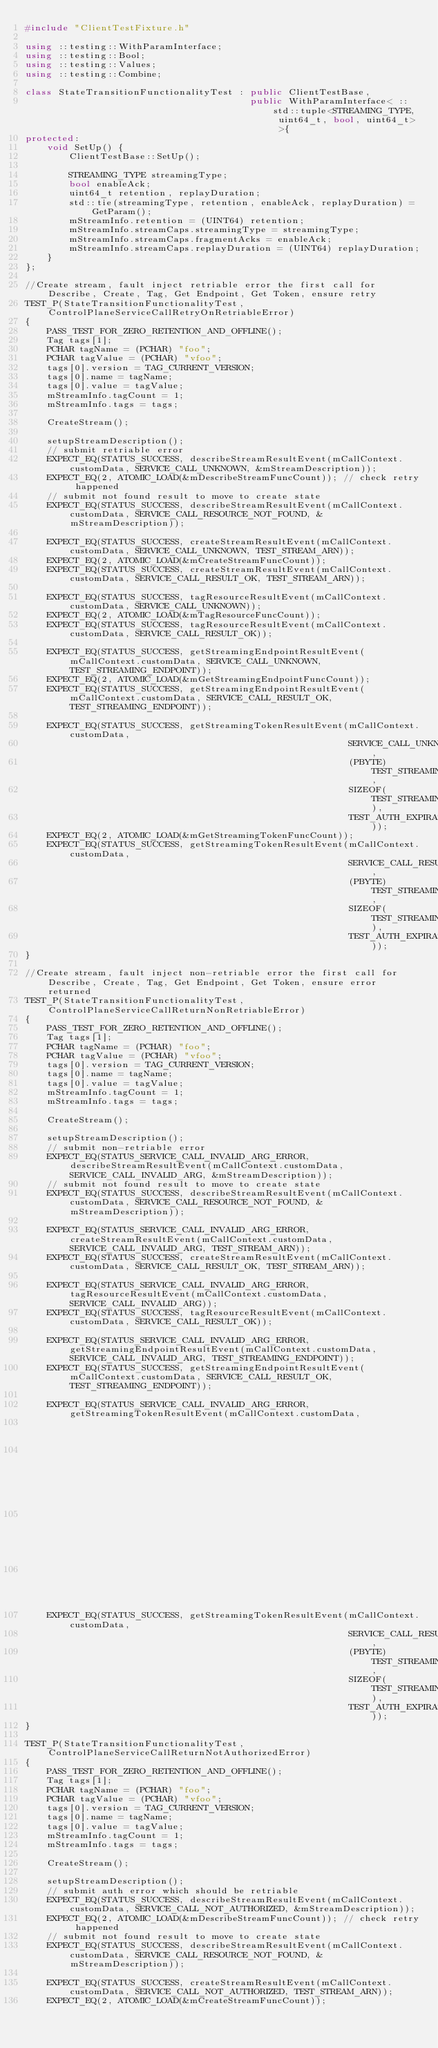<code> <loc_0><loc_0><loc_500><loc_500><_C++_>#include "ClientTestFixture.h"

using ::testing::WithParamInterface;
using ::testing::Bool;
using ::testing::Values;
using ::testing::Combine;

class StateTransitionFunctionalityTest : public ClientTestBase,
                                         public WithParamInterface< ::std::tuple<STREAMING_TYPE, uint64_t, bool, uint64_t> >{
protected:
    void SetUp() {
        ClientTestBase::SetUp();

        STREAMING_TYPE streamingType;
        bool enableAck;
        uint64_t retention, replayDuration;
        std::tie(streamingType, retention, enableAck, replayDuration) = GetParam();
        mStreamInfo.retention = (UINT64) retention;
        mStreamInfo.streamCaps.streamingType = streamingType;
        mStreamInfo.streamCaps.fragmentAcks = enableAck;
        mStreamInfo.streamCaps.replayDuration = (UINT64) replayDuration;
    }
};

//Create stream, fault inject retriable error the first call for Describe, Create, Tag, Get Endpoint, Get Token, ensure retry
TEST_P(StateTransitionFunctionalityTest, ControlPlaneServiceCallRetryOnRetriableError)
{
    PASS_TEST_FOR_ZERO_RETENTION_AND_OFFLINE();
    Tag tags[1];
    PCHAR tagName = (PCHAR) "foo";
    PCHAR tagValue = (PCHAR) "vfoo";
    tags[0].version = TAG_CURRENT_VERSION;
    tags[0].name = tagName;
    tags[0].value = tagValue;
    mStreamInfo.tagCount = 1;
    mStreamInfo.tags = tags;

    CreateStream();

    setupStreamDescription();
    // submit retriable error
    EXPECT_EQ(STATUS_SUCCESS, describeStreamResultEvent(mCallContext.customData, SERVICE_CALL_UNKNOWN, &mStreamDescription));
    EXPECT_EQ(2, ATOMIC_LOAD(&mDescribeStreamFuncCount)); // check retry happened
    // submit not found result to move to create state
    EXPECT_EQ(STATUS_SUCCESS, describeStreamResultEvent(mCallContext.customData, SERVICE_CALL_RESOURCE_NOT_FOUND, &mStreamDescription));

    EXPECT_EQ(STATUS_SUCCESS, createStreamResultEvent(mCallContext.customData, SERVICE_CALL_UNKNOWN, TEST_STREAM_ARN));
    EXPECT_EQ(2, ATOMIC_LOAD(&mCreateStreamFuncCount));
    EXPECT_EQ(STATUS_SUCCESS, createStreamResultEvent(mCallContext.customData, SERVICE_CALL_RESULT_OK, TEST_STREAM_ARN));

    EXPECT_EQ(STATUS_SUCCESS, tagResourceResultEvent(mCallContext.customData, SERVICE_CALL_UNKNOWN));
    EXPECT_EQ(2, ATOMIC_LOAD(&mTagResourceFuncCount));
    EXPECT_EQ(STATUS_SUCCESS, tagResourceResultEvent(mCallContext.customData, SERVICE_CALL_RESULT_OK));

    EXPECT_EQ(STATUS_SUCCESS, getStreamingEndpointResultEvent(mCallContext.customData, SERVICE_CALL_UNKNOWN, TEST_STREAMING_ENDPOINT));
    EXPECT_EQ(2, ATOMIC_LOAD(&mGetStreamingEndpointFuncCount));
    EXPECT_EQ(STATUS_SUCCESS, getStreamingEndpointResultEvent(mCallContext.customData, SERVICE_CALL_RESULT_OK, TEST_STREAMING_ENDPOINT));

    EXPECT_EQ(STATUS_SUCCESS, getStreamingTokenResultEvent(mCallContext.customData,
                                                           SERVICE_CALL_UNKNOWN,
                                                           (PBYTE) TEST_STREAMING_TOKEN,
                                                           SIZEOF(TEST_STREAMING_TOKEN),
                                                           TEST_AUTH_EXPIRATION));
    EXPECT_EQ(2, ATOMIC_LOAD(&mGetStreamingTokenFuncCount));
    EXPECT_EQ(STATUS_SUCCESS, getStreamingTokenResultEvent(mCallContext.customData,
                                                           SERVICE_CALL_RESULT_OK,
                                                           (PBYTE) TEST_STREAMING_TOKEN,
                                                           SIZEOF(TEST_STREAMING_TOKEN),
                                                           TEST_AUTH_EXPIRATION));
}

//Create stream, fault inject non-retriable error the first call for Describe, Create, Tag, Get Endpoint, Get Token, ensure error returned
TEST_P(StateTransitionFunctionalityTest, ControlPlaneServiceCallReturnNonRetriableError)
{
    PASS_TEST_FOR_ZERO_RETENTION_AND_OFFLINE();
    Tag tags[1];
    PCHAR tagName = (PCHAR) "foo";
    PCHAR tagValue = (PCHAR) "vfoo";
    tags[0].version = TAG_CURRENT_VERSION;
    tags[0].name = tagName;
    tags[0].value = tagValue;
    mStreamInfo.tagCount = 1;
    mStreamInfo.tags = tags;

    CreateStream();

    setupStreamDescription();
    // submit non-retriable error
    EXPECT_EQ(STATUS_SERVICE_CALL_INVALID_ARG_ERROR, describeStreamResultEvent(mCallContext.customData, SERVICE_CALL_INVALID_ARG, &mStreamDescription));
    // submit not found result to move to create state
    EXPECT_EQ(STATUS_SUCCESS, describeStreamResultEvent(mCallContext.customData, SERVICE_CALL_RESOURCE_NOT_FOUND, &mStreamDescription));

    EXPECT_EQ(STATUS_SERVICE_CALL_INVALID_ARG_ERROR, createStreamResultEvent(mCallContext.customData, SERVICE_CALL_INVALID_ARG, TEST_STREAM_ARN));
    EXPECT_EQ(STATUS_SUCCESS, createStreamResultEvent(mCallContext.customData, SERVICE_CALL_RESULT_OK, TEST_STREAM_ARN));

    EXPECT_EQ(STATUS_SERVICE_CALL_INVALID_ARG_ERROR, tagResourceResultEvent(mCallContext.customData, SERVICE_CALL_INVALID_ARG));
    EXPECT_EQ(STATUS_SUCCESS, tagResourceResultEvent(mCallContext.customData, SERVICE_CALL_RESULT_OK));

    EXPECT_EQ(STATUS_SERVICE_CALL_INVALID_ARG_ERROR, getStreamingEndpointResultEvent(mCallContext.customData, SERVICE_CALL_INVALID_ARG, TEST_STREAMING_ENDPOINT));
    EXPECT_EQ(STATUS_SUCCESS, getStreamingEndpointResultEvent(mCallContext.customData, SERVICE_CALL_RESULT_OK, TEST_STREAMING_ENDPOINT));

    EXPECT_EQ(STATUS_SERVICE_CALL_INVALID_ARG_ERROR, getStreamingTokenResultEvent(mCallContext.customData,
                                                                                  SERVICE_CALL_INVALID_ARG,
                                                                                  (PBYTE) TEST_STREAMING_TOKEN,
                                                                                  SIZEOF(TEST_STREAMING_TOKEN),
                                                                                  TEST_AUTH_EXPIRATION));
    EXPECT_EQ(STATUS_SUCCESS, getStreamingTokenResultEvent(mCallContext.customData,
                                                           SERVICE_CALL_RESULT_OK,
                                                           (PBYTE) TEST_STREAMING_TOKEN,
                                                           SIZEOF(TEST_STREAMING_TOKEN),
                                                           TEST_AUTH_EXPIRATION));
}

TEST_P(StateTransitionFunctionalityTest, ControlPlaneServiceCallReturnNotAuthorizedError)
{
    PASS_TEST_FOR_ZERO_RETENTION_AND_OFFLINE();
    Tag tags[1];
    PCHAR tagName = (PCHAR) "foo";
    PCHAR tagValue = (PCHAR) "vfoo";
    tags[0].version = TAG_CURRENT_VERSION;
    tags[0].name = tagName;
    tags[0].value = tagValue;
    mStreamInfo.tagCount = 1;
    mStreamInfo.tags = tags;

    CreateStream();

    setupStreamDescription();
    // submit auth error which should be retriable
    EXPECT_EQ(STATUS_SUCCESS, describeStreamResultEvent(mCallContext.customData, SERVICE_CALL_NOT_AUTHORIZED, &mStreamDescription));
    EXPECT_EQ(2, ATOMIC_LOAD(&mDescribeStreamFuncCount)); // check retry happened
    // submit not found result to move to create state
    EXPECT_EQ(STATUS_SUCCESS, describeStreamResultEvent(mCallContext.customData, SERVICE_CALL_RESOURCE_NOT_FOUND, &mStreamDescription));

    EXPECT_EQ(STATUS_SUCCESS, createStreamResultEvent(mCallContext.customData, SERVICE_CALL_NOT_AUTHORIZED, TEST_STREAM_ARN));
    EXPECT_EQ(2, ATOMIC_LOAD(&mCreateStreamFuncCount));</code> 